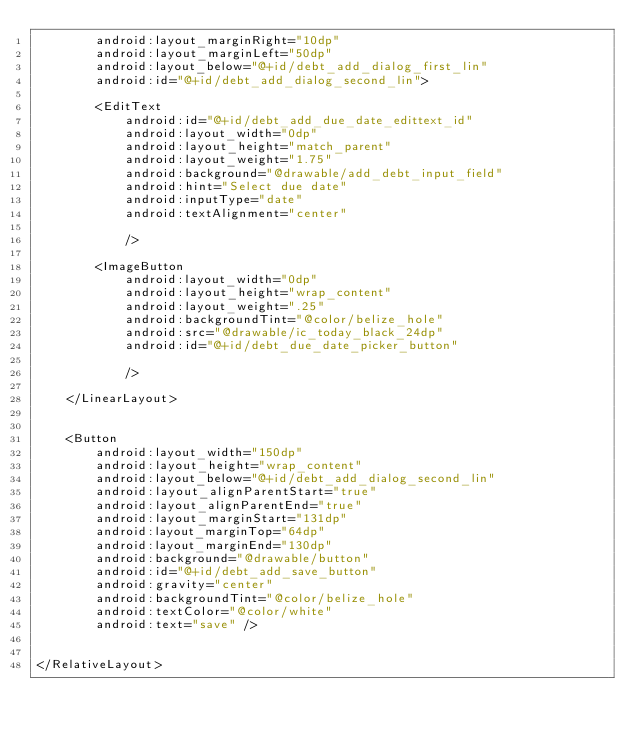Convert code to text. <code><loc_0><loc_0><loc_500><loc_500><_XML_>        android:layout_marginRight="10dp"
        android:layout_marginLeft="50dp"
        android:layout_below="@+id/debt_add_dialog_first_lin"
        android:id="@+id/debt_add_dialog_second_lin">

        <EditText
            android:id="@+id/debt_add_due_date_edittext_id"
            android:layout_width="0dp"
            android:layout_height="match_parent"
            android:layout_weight="1.75"
            android:background="@drawable/add_debt_input_field"
            android:hint="Select due date"
            android:inputType="date"
            android:textAlignment="center"

            />

        <ImageButton
            android:layout_width="0dp"
            android:layout_height="wrap_content"
            android:layout_weight=".25"
            android:backgroundTint="@color/belize_hole"
            android:src="@drawable/ic_today_black_24dp"
            android:id="@+id/debt_due_date_picker_button"

            />

    </LinearLayout>


    <Button
        android:layout_width="150dp"
        android:layout_height="wrap_content"
        android:layout_below="@+id/debt_add_dialog_second_lin"
        android:layout_alignParentStart="true"
        android:layout_alignParentEnd="true"
        android:layout_marginStart="131dp"
        android:layout_marginTop="64dp"
        android:layout_marginEnd="130dp"
        android:background="@drawable/button"
        android:id="@+id/debt_add_save_button"
        android:gravity="center"
        android:backgroundTint="@color/belize_hole"
        android:textColor="@color/white"
        android:text="save" />


</RelativeLayout>
</code> 